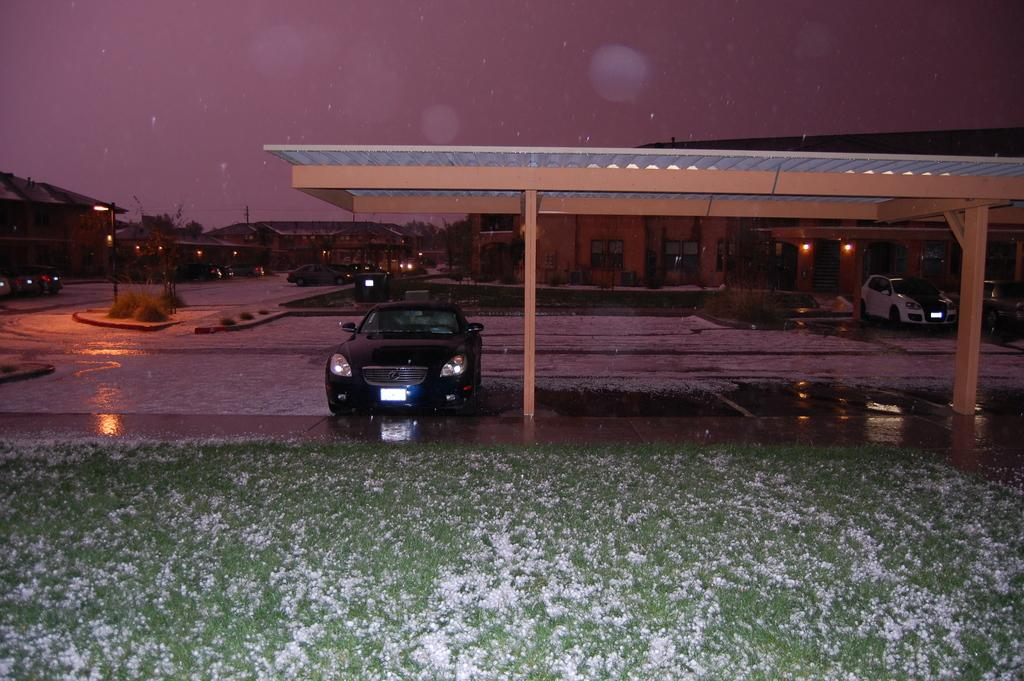What type of outdoor area is shown in the image? There is a garden in the image. What structure can be seen in the garden? There is a shed in the image. What is parked under the shed? A car is parked under the shed. What can be seen in the distance in the image? There are houses visible in the background of the image. What is visible above the houses in the image? The sky is visible in the background of the image. What type of spy equipment can be seen in the garden? There is no spy equipment visible in the image; it features a garden, a shed, a car, houses in the background, and the sky. What type of sticks are used to prepare the dinner in the image? There is no dinner preparation or sticks visible in the image. 